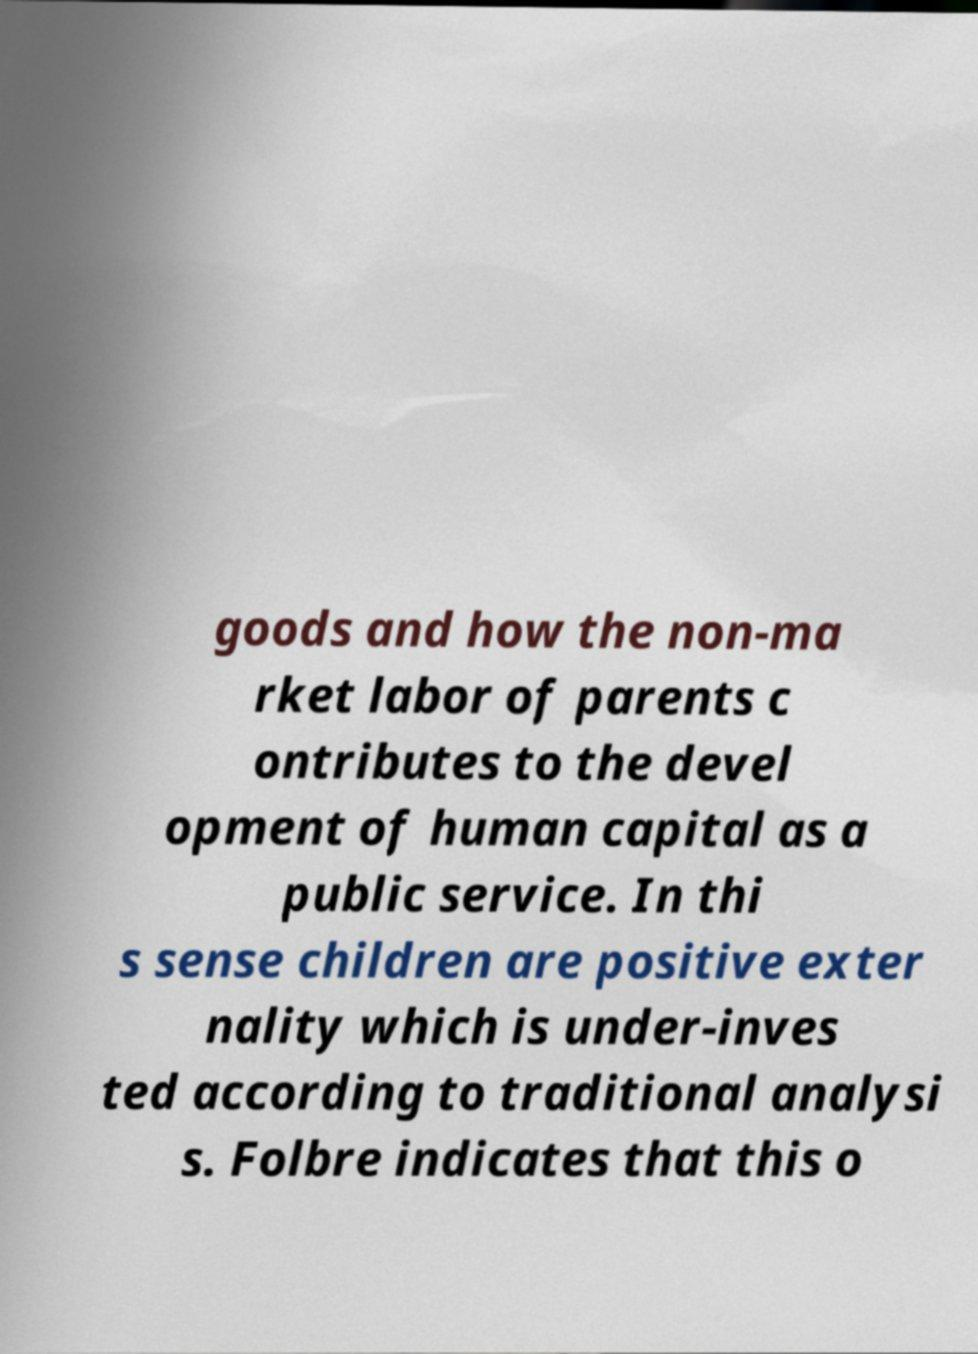There's text embedded in this image that I need extracted. Can you transcribe it verbatim? goods and how the non-ma rket labor of parents c ontributes to the devel opment of human capital as a public service. In thi s sense children are positive exter nality which is under-inves ted according to traditional analysi s. Folbre indicates that this o 